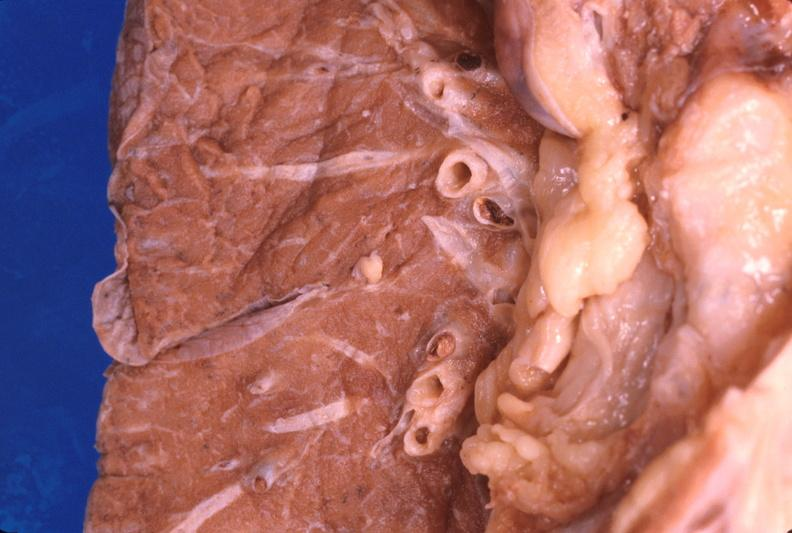s respiratory present?
Answer the question using a single word or phrase. Yes 